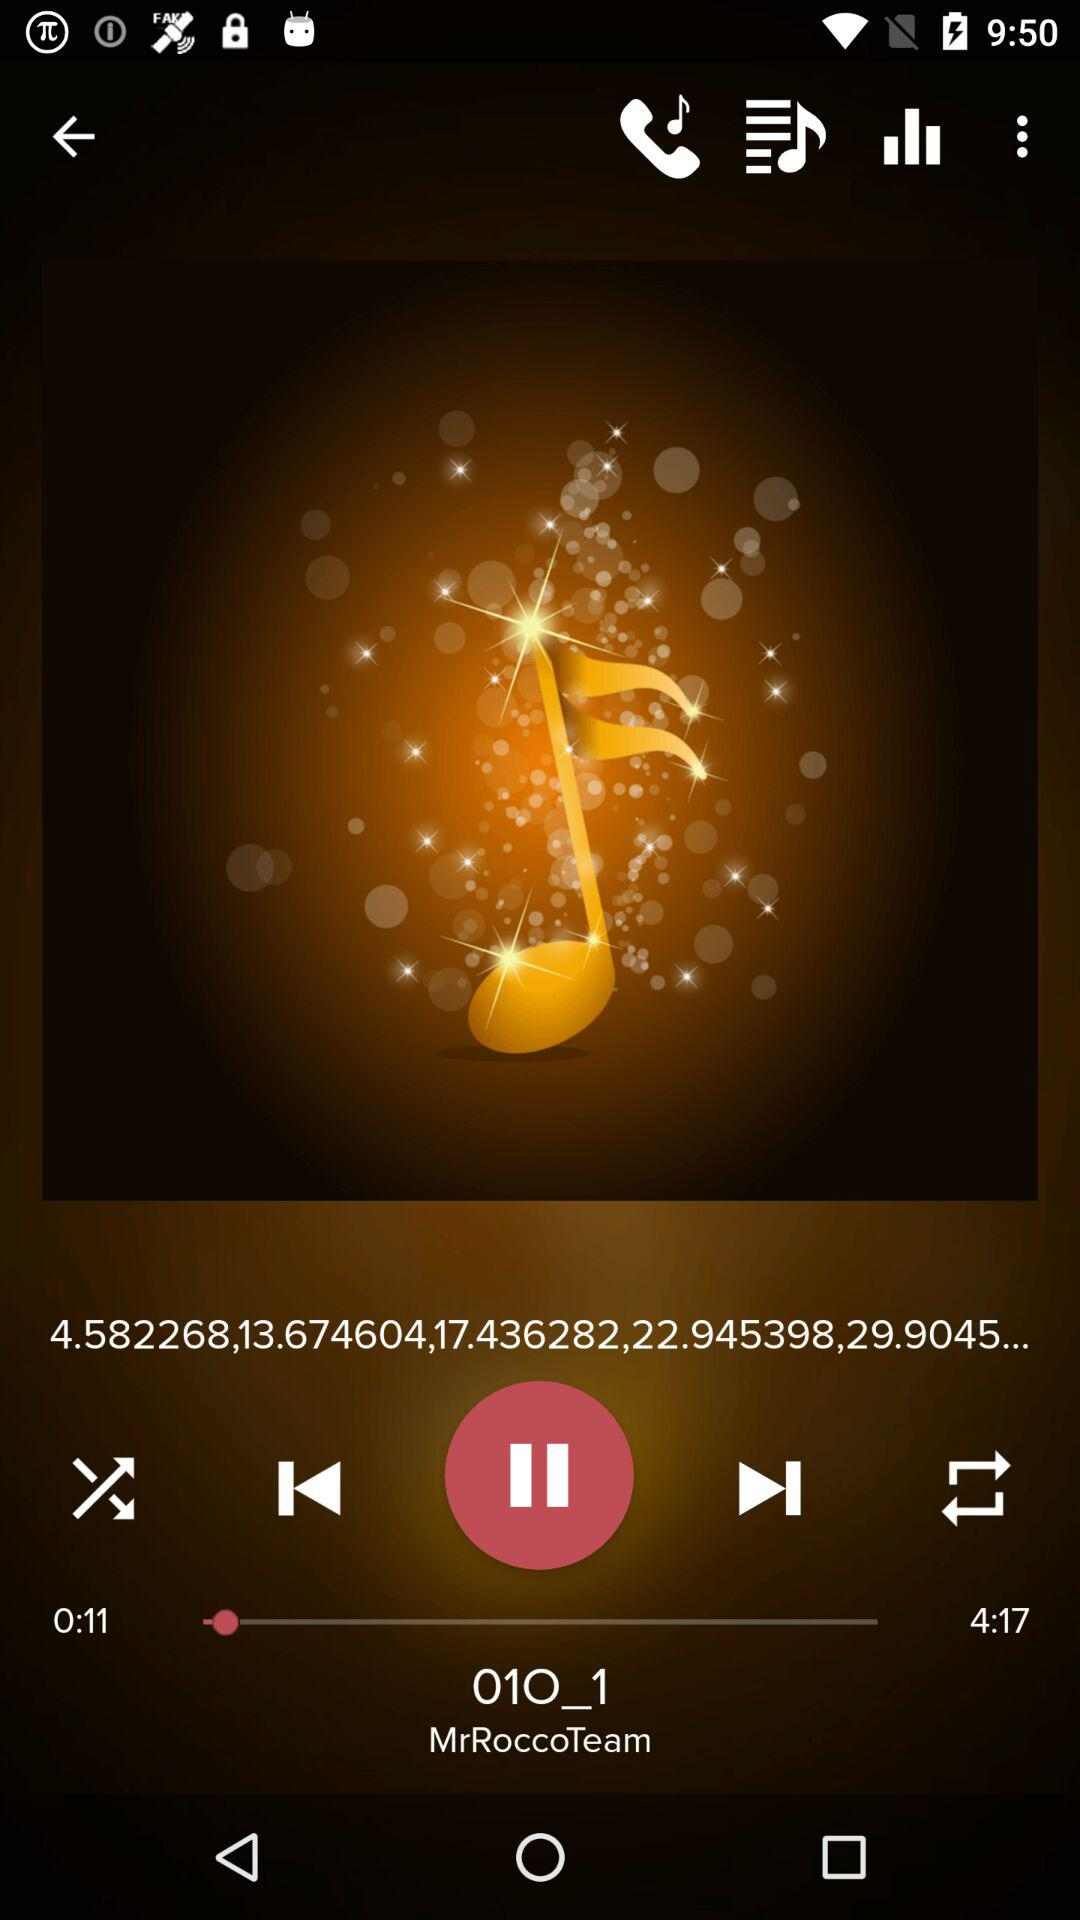What is the total duration of the playing audio? The total duration of the playing audio is 4 minutes 17 seconds. 